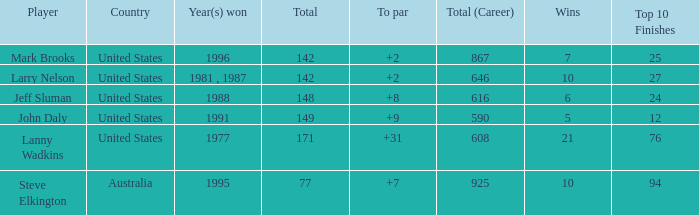Name the Total of jeff sluman? 148.0. 